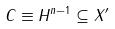Convert formula to latex. <formula><loc_0><loc_0><loc_500><loc_500>C \equiv H ^ { n - 1 } \subseteq X ^ { \prime }</formula> 